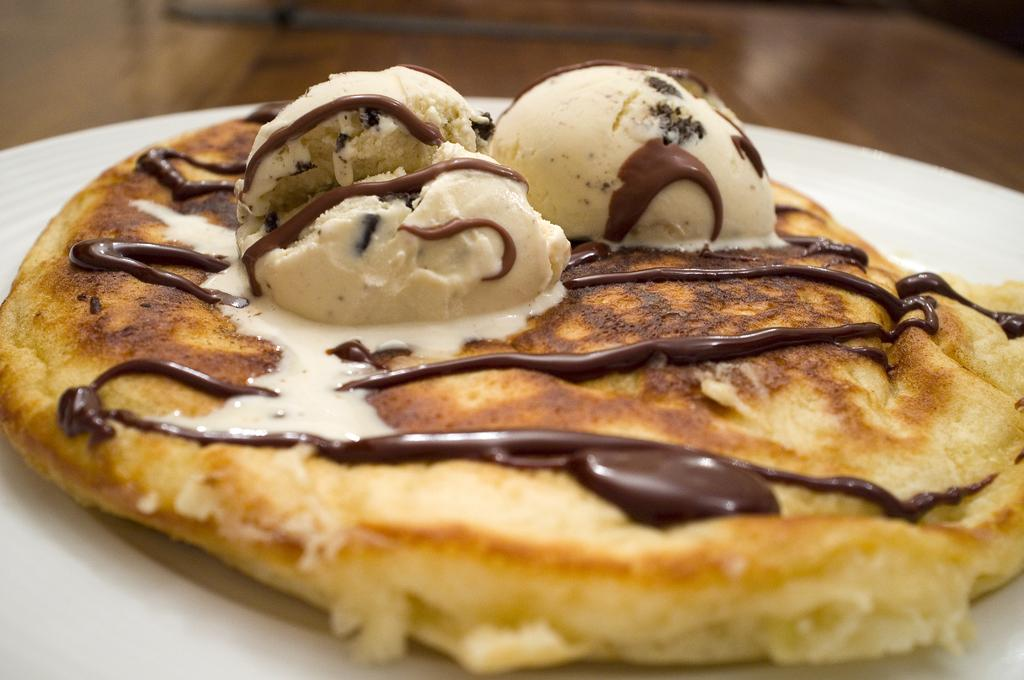What is on the plate that is visible in the image? There is food on the plate in the image. What is the plate resting on? The plate is on a wooden platform. What type of lace is draped over the sink in the image? There is no lace or sink present in the image; it only features a plate with food on a wooden platform. 